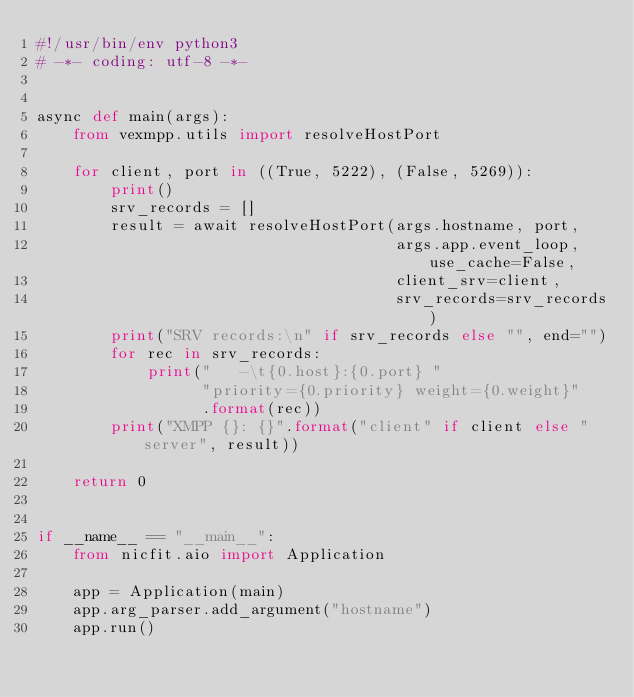<code> <loc_0><loc_0><loc_500><loc_500><_Python_>#!/usr/bin/env python3
# -*- coding: utf-8 -*-


async def main(args):
    from vexmpp.utils import resolveHostPort

    for client, port in ((True, 5222), (False, 5269)):
        print()
        srv_records = []
        result = await resolveHostPort(args.hostname, port,
                                       args.app.event_loop, use_cache=False,
                                       client_srv=client,
                                       srv_records=srv_records)
        print("SRV records:\n" if srv_records else "", end="")
        for rec in srv_records:
            print("   -\t{0.host}:{0.port} "
                  "priority={0.priority} weight={0.weight}"
                  .format(rec))
        print("XMPP {}: {}".format("client" if client else "server", result))

    return 0


if __name__ == "__main__":
    from nicfit.aio import Application

    app = Application(main)
    app.arg_parser.add_argument("hostname")
    app.run()
</code> 